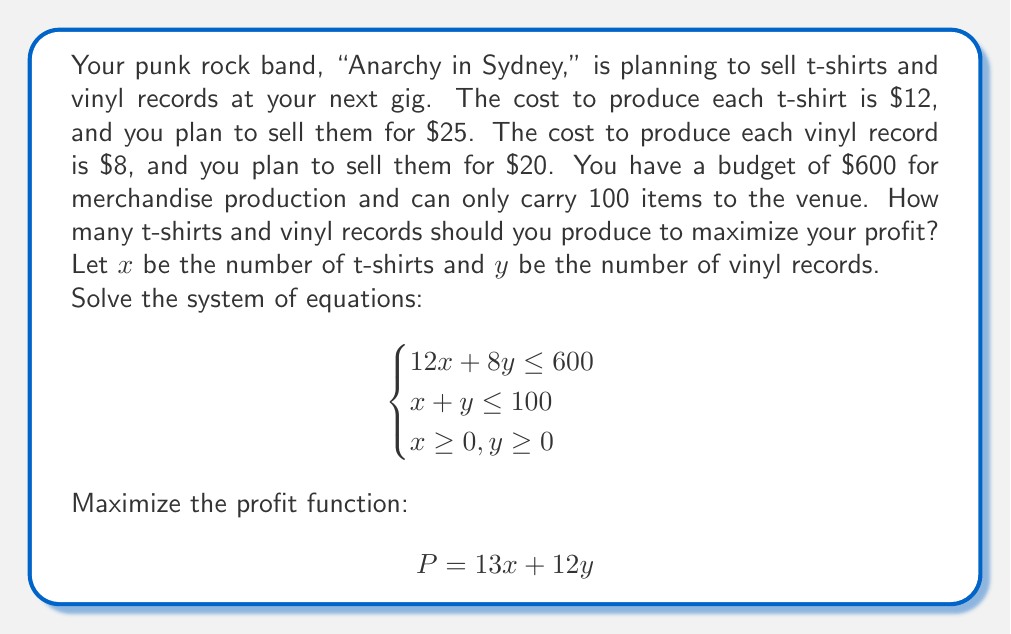Can you solve this math problem? To solve this problem, we'll use the following steps:

1. Graph the constraints:
   a) $12x + 8y = 600$ (Budget constraint)
   b) $x + y = 100$ (Capacity constraint)
   c) $x \geq 0, y \geq 0$ (Non-negativity constraints)

2. Find the intersection points of the constraints:
   a) $(0, 75)$ - where the budget line intersects the y-axis
   b) $(50, 0)$ - where the budget line intersects the x-axis
   c) $(0, 100)$ - where the capacity line intersects the y-axis
   d) $(100, 0)$ - where the capacity line intersects the x-axis
   e) The intersection of budget and capacity lines:
      Solve $12x + 8y = 600$ and $x + y = 100$
      Substituting $y = 100 - x$ into the budget equation:
      $12x + 8(100 - x) = 600$
      $12x + 800 - 8x = 600$
      $4x = -200$
      $x = -50$ (not in the feasible region)

3. The feasible region is bounded by the points $(0, 75)$, $(50, 50)$, and $(75, 25)$.

4. Evaluate the profit function at each corner point:
   a) $(0, 75)$: $P = 13(0) + 12(75) = 900$
   b) $(50, 50)$: $P = 13(50) + 12(50) = 1250$
   c) $(75, 25)$: $P = 13(75) + 12(25) = 1275$

5. The maximum profit occurs at the point $(75, 25)$.

Therefore, to maximize profit, the band should produce 75 t-shirts and 25 vinyl records.
Answer: 75 t-shirts and 25 vinyl records 